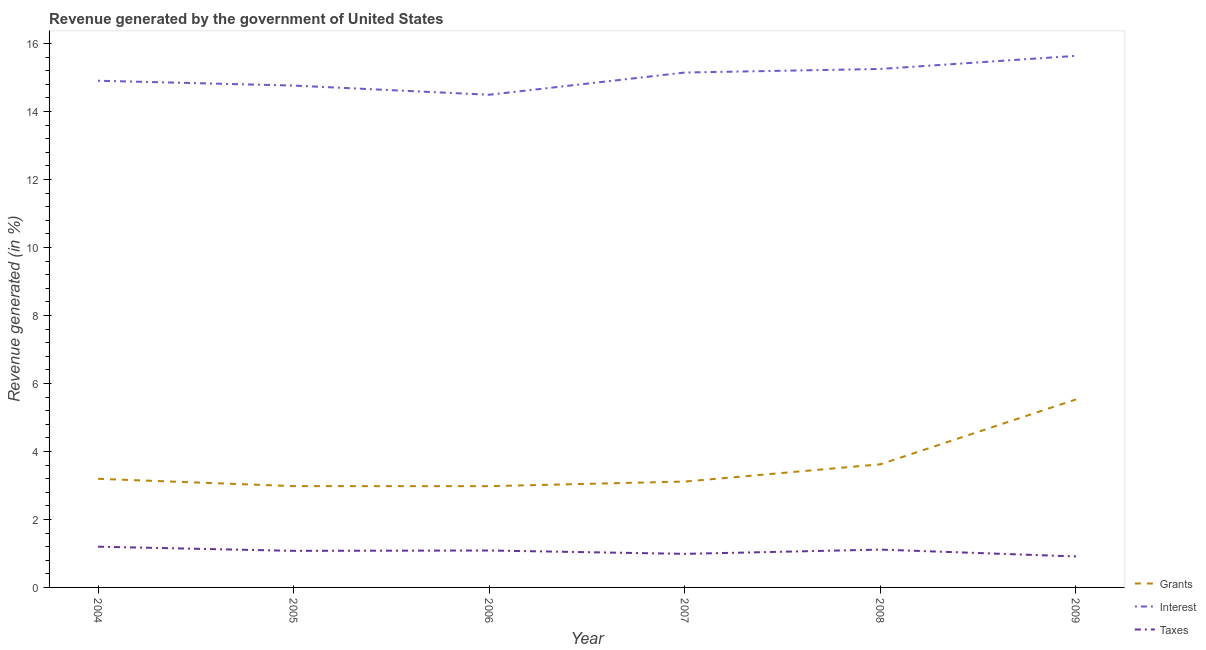How many different coloured lines are there?
Your answer should be very brief. 3. Is the number of lines equal to the number of legend labels?
Your answer should be compact. Yes. What is the percentage of revenue generated by grants in 2005?
Make the answer very short. 2.98. Across all years, what is the maximum percentage of revenue generated by interest?
Offer a very short reply. 15.64. Across all years, what is the minimum percentage of revenue generated by interest?
Keep it short and to the point. 14.49. In which year was the percentage of revenue generated by interest minimum?
Ensure brevity in your answer.  2006. What is the total percentage of revenue generated by interest in the graph?
Offer a terse response. 90.19. What is the difference between the percentage of revenue generated by interest in 2007 and that in 2009?
Your answer should be very brief. -0.49. What is the difference between the percentage of revenue generated by interest in 2005 and the percentage of revenue generated by grants in 2009?
Make the answer very short. 9.23. What is the average percentage of revenue generated by interest per year?
Your answer should be very brief. 15.03. In the year 2004, what is the difference between the percentage of revenue generated by interest and percentage of revenue generated by grants?
Offer a very short reply. 11.71. In how many years, is the percentage of revenue generated by grants greater than 7.2 %?
Your response must be concise. 0. What is the ratio of the percentage of revenue generated by taxes in 2006 to that in 2009?
Offer a very short reply. 1.19. What is the difference between the highest and the second highest percentage of revenue generated by grants?
Ensure brevity in your answer.  1.91. What is the difference between the highest and the lowest percentage of revenue generated by interest?
Your response must be concise. 1.14. In how many years, is the percentage of revenue generated by interest greater than the average percentage of revenue generated by interest taken over all years?
Keep it short and to the point. 3. Is the sum of the percentage of revenue generated by grants in 2005 and 2009 greater than the maximum percentage of revenue generated by taxes across all years?
Your answer should be compact. Yes. Is it the case that in every year, the sum of the percentage of revenue generated by grants and percentage of revenue generated by interest is greater than the percentage of revenue generated by taxes?
Your answer should be very brief. Yes. How many lines are there?
Your answer should be very brief. 3. How many years are there in the graph?
Give a very brief answer. 6. What is the difference between two consecutive major ticks on the Y-axis?
Make the answer very short. 2. Are the values on the major ticks of Y-axis written in scientific E-notation?
Offer a terse response. No. Does the graph contain any zero values?
Provide a short and direct response. No. Where does the legend appear in the graph?
Offer a terse response. Bottom right. How many legend labels are there?
Make the answer very short. 3. How are the legend labels stacked?
Your response must be concise. Vertical. What is the title of the graph?
Keep it short and to the point. Revenue generated by the government of United States. What is the label or title of the Y-axis?
Your answer should be compact. Revenue generated (in %). What is the Revenue generated (in %) in Grants in 2004?
Offer a very short reply. 3.2. What is the Revenue generated (in %) in Interest in 2004?
Your response must be concise. 14.9. What is the Revenue generated (in %) of Taxes in 2004?
Your answer should be very brief. 1.2. What is the Revenue generated (in %) of Grants in 2005?
Your response must be concise. 2.98. What is the Revenue generated (in %) in Interest in 2005?
Your answer should be compact. 14.76. What is the Revenue generated (in %) in Taxes in 2005?
Keep it short and to the point. 1.08. What is the Revenue generated (in %) in Grants in 2006?
Ensure brevity in your answer.  2.98. What is the Revenue generated (in %) in Interest in 2006?
Your answer should be very brief. 14.49. What is the Revenue generated (in %) in Taxes in 2006?
Provide a succinct answer. 1.09. What is the Revenue generated (in %) in Grants in 2007?
Give a very brief answer. 3.11. What is the Revenue generated (in %) in Interest in 2007?
Keep it short and to the point. 15.15. What is the Revenue generated (in %) in Taxes in 2007?
Provide a succinct answer. 0.99. What is the Revenue generated (in %) in Grants in 2008?
Ensure brevity in your answer.  3.62. What is the Revenue generated (in %) in Interest in 2008?
Your response must be concise. 15.25. What is the Revenue generated (in %) of Taxes in 2008?
Your answer should be very brief. 1.11. What is the Revenue generated (in %) of Grants in 2009?
Give a very brief answer. 5.53. What is the Revenue generated (in %) in Interest in 2009?
Give a very brief answer. 15.64. What is the Revenue generated (in %) in Taxes in 2009?
Ensure brevity in your answer.  0.91. Across all years, what is the maximum Revenue generated (in %) in Grants?
Your response must be concise. 5.53. Across all years, what is the maximum Revenue generated (in %) in Interest?
Provide a succinct answer. 15.64. Across all years, what is the maximum Revenue generated (in %) in Taxes?
Ensure brevity in your answer.  1.2. Across all years, what is the minimum Revenue generated (in %) of Grants?
Your answer should be compact. 2.98. Across all years, what is the minimum Revenue generated (in %) of Interest?
Your response must be concise. 14.49. Across all years, what is the minimum Revenue generated (in %) in Taxes?
Provide a succinct answer. 0.91. What is the total Revenue generated (in %) of Grants in the graph?
Offer a very short reply. 21.42. What is the total Revenue generated (in %) in Interest in the graph?
Ensure brevity in your answer.  90.19. What is the total Revenue generated (in %) of Taxes in the graph?
Give a very brief answer. 6.37. What is the difference between the Revenue generated (in %) in Grants in 2004 and that in 2005?
Offer a very short reply. 0.22. What is the difference between the Revenue generated (in %) of Interest in 2004 and that in 2005?
Your answer should be compact. 0.14. What is the difference between the Revenue generated (in %) in Taxes in 2004 and that in 2005?
Your response must be concise. 0.12. What is the difference between the Revenue generated (in %) of Grants in 2004 and that in 2006?
Your response must be concise. 0.22. What is the difference between the Revenue generated (in %) of Interest in 2004 and that in 2006?
Make the answer very short. 0.41. What is the difference between the Revenue generated (in %) in Taxes in 2004 and that in 2006?
Your response must be concise. 0.11. What is the difference between the Revenue generated (in %) in Grants in 2004 and that in 2007?
Provide a succinct answer. 0.08. What is the difference between the Revenue generated (in %) of Interest in 2004 and that in 2007?
Provide a succinct answer. -0.24. What is the difference between the Revenue generated (in %) of Taxes in 2004 and that in 2007?
Your response must be concise. 0.21. What is the difference between the Revenue generated (in %) of Grants in 2004 and that in 2008?
Offer a very short reply. -0.43. What is the difference between the Revenue generated (in %) of Interest in 2004 and that in 2008?
Offer a very short reply. -0.35. What is the difference between the Revenue generated (in %) in Taxes in 2004 and that in 2008?
Give a very brief answer. 0.09. What is the difference between the Revenue generated (in %) in Grants in 2004 and that in 2009?
Your answer should be very brief. -2.34. What is the difference between the Revenue generated (in %) in Interest in 2004 and that in 2009?
Your answer should be very brief. -0.73. What is the difference between the Revenue generated (in %) in Taxes in 2004 and that in 2009?
Keep it short and to the point. 0.29. What is the difference between the Revenue generated (in %) of Grants in 2005 and that in 2006?
Provide a short and direct response. 0. What is the difference between the Revenue generated (in %) in Interest in 2005 and that in 2006?
Your answer should be very brief. 0.27. What is the difference between the Revenue generated (in %) in Taxes in 2005 and that in 2006?
Provide a succinct answer. -0.01. What is the difference between the Revenue generated (in %) in Grants in 2005 and that in 2007?
Offer a terse response. -0.13. What is the difference between the Revenue generated (in %) in Interest in 2005 and that in 2007?
Keep it short and to the point. -0.38. What is the difference between the Revenue generated (in %) of Taxes in 2005 and that in 2007?
Make the answer very short. 0.09. What is the difference between the Revenue generated (in %) in Grants in 2005 and that in 2008?
Make the answer very short. -0.64. What is the difference between the Revenue generated (in %) of Interest in 2005 and that in 2008?
Give a very brief answer. -0.49. What is the difference between the Revenue generated (in %) in Taxes in 2005 and that in 2008?
Offer a terse response. -0.04. What is the difference between the Revenue generated (in %) of Grants in 2005 and that in 2009?
Provide a short and direct response. -2.55. What is the difference between the Revenue generated (in %) in Interest in 2005 and that in 2009?
Provide a short and direct response. -0.87. What is the difference between the Revenue generated (in %) of Taxes in 2005 and that in 2009?
Provide a succinct answer. 0.16. What is the difference between the Revenue generated (in %) in Grants in 2006 and that in 2007?
Your answer should be compact. -0.14. What is the difference between the Revenue generated (in %) in Interest in 2006 and that in 2007?
Your answer should be compact. -0.65. What is the difference between the Revenue generated (in %) of Taxes in 2006 and that in 2007?
Offer a terse response. 0.1. What is the difference between the Revenue generated (in %) in Grants in 2006 and that in 2008?
Offer a terse response. -0.64. What is the difference between the Revenue generated (in %) of Interest in 2006 and that in 2008?
Provide a short and direct response. -0.76. What is the difference between the Revenue generated (in %) in Taxes in 2006 and that in 2008?
Your answer should be compact. -0.03. What is the difference between the Revenue generated (in %) in Grants in 2006 and that in 2009?
Provide a succinct answer. -2.55. What is the difference between the Revenue generated (in %) of Interest in 2006 and that in 2009?
Your response must be concise. -1.14. What is the difference between the Revenue generated (in %) of Taxes in 2006 and that in 2009?
Offer a terse response. 0.17. What is the difference between the Revenue generated (in %) of Grants in 2007 and that in 2008?
Your response must be concise. -0.51. What is the difference between the Revenue generated (in %) in Interest in 2007 and that in 2008?
Provide a succinct answer. -0.11. What is the difference between the Revenue generated (in %) of Taxes in 2007 and that in 2008?
Give a very brief answer. -0.13. What is the difference between the Revenue generated (in %) of Grants in 2007 and that in 2009?
Your answer should be compact. -2.42. What is the difference between the Revenue generated (in %) of Interest in 2007 and that in 2009?
Your answer should be compact. -0.49. What is the difference between the Revenue generated (in %) in Taxes in 2007 and that in 2009?
Give a very brief answer. 0.08. What is the difference between the Revenue generated (in %) in Grants in 2008 and that in 2009?
Offer a very short reply. -1.91. What is the difference between the Revenue generated (in %) in Interest in 2008 and that in 2009?
Provide a short and direct response. -0.38. What is the difference between the Revenue generated (in %) in Taxes in 2008 and that in 2009?
Ensure brevity in your answer.  0.2. What is the difference between the Revenue generated (in %) in Grants in 2004 and the Revenue generated (in %) in Interest in 2005?
Your response must be concise. -11.57. What is the difference between the Revenue generated (in %) in Grants in 2004 and the Revenue generated (in %) in Taxes in 2005?
Your response must be concise. 2.12. What is the difference between the Revenue generated (in %) in Interest in 2004 and the Revenue generated (in %) in Taxes in 2005?
Give a very brief answer. 13.83. What is the difference between the Revenue generated (in %) in Grants in 2004 and the Revenue generated (in %) in Interest in 2006?
Offer a terse response. -11.3. What is the difference between the Revenue generated (in %) of Grants in 2004 and the Revenue generated (in %) of Taxes in 2006?
Your response must be concise. 2.11. What is the difference between the Revenue generated (in %) in Interest in 2004 and the Revenue generated (in %) in Taxes in 2006?
Keep it short and to the point. 13.82. What is the difference between the Revenue generated (in %) in Grants in 2004 and the Revenue generated (in %) in Interest in 2007?
Offer a very short reply. -11.95. What is the difference between the Revenue generated (in %) of Grants in 2004 and the Revenue generated (in %) of Taxes in 2007?
Give a very brief answer. 2.21. What is the difference between the Revenue generated (in %) of Interest in 2004 and the Revenue generated (in %) of Taxes in 2007?
Your answer should be very brief. 13.92. What is the difference between the Revenue generated (in %) in Grants in 2004 and the Revenue generated (in %) in Interest in 2008?
Provide a succinct answer. -12.06. What is the difference between the Revenue generated (in %) in Grants in 2004 and the Revenue generated (in %) in Taxes in 2008?
Make the answer very short. 2.08. What is the difference between the Revenue generated (in %) in Interest in 2004 and the Revenue generated (in %) in Taxes in 2008?
Provide a short and direct response. 13.79. What is the difference between the Revenue generated (in %) of Grants in 2004 and the Revenue generated (in %) of Interest in 2009?
Keep it short and to the point. -12.44. What is the difference between the Revenue generated (in %) in Grants in 2004 and the Revenue generated (in %) in Taxes in 2009?
Offer a very short reply. 2.28. What is the difference between the Revenue generated (in %) of Interest in 2004 and the Revenue generated (in %) of Taxes in 2009?
Offer a very short reply. 13.99. What is the difference between the Revenue generated (in %) of Grants in 2005 and the Revenue generated (in %) of Interest in 2006?
Your response must be concise. -11.51. What is the difference between the Revenue generated (in %) in Grants in 2005 and the Revenue generated (in %) in Taxes in 2006?
Give a very brief answer. 1.89. What is the difference between the Revenue generated (in %) of Interest in 2005 and the Revenue generated (in %) of Taxes in 2006?
Provide a short and direct response. 13.68. What is the difference between the Revenue generated (in %) of Grants in 2005 and the Revenue generated (in %) of Interest in 2007?
Offer a very short reply. -12.17. What is the difference between the Revenue generated (in %) of Grants in 2005 and the Revenue generated (in %) of Taxes in 2007?
Your answer should be very brief. 1.99. What is the difference between the Revenue generated (in %) in Interest in 2005 and the Revenue generated (in %) in Taxes in 2007?
Make the answer very short. 13.77. What is the difference between the Revenue generated (in %) of Grants in 2005 and the Revenue generated (in %) of Interest in 2008?
Ensure brevity in your answer.  -12.27. What is the difference between the Revenue generated (in %) of Grants in 2005 and the Revenue generated (in %) of Taxes in 2008?
Your response must be concise. 1.87. What is the difference between the Revenue generated (in %) of Interest in 2005 and the Revenue generated (in %) of Taxes in 2008?
Your answer should be very brief. 13.65. What is the difference between the Revenue generated (in %) in Grants in 2005 and the Revenue generated (in %) in Interest in 2009?
Your answer should be very brief. -12.66. What is the difference between the Revenue generated (in %) in Grants in 2005 and the Revenue generated (in %) in Taxes in 2009?
Offer a very short reply. 2.07. What is the difference between the Revenue generated (in %) in Interest in 2005 and the Revenue generated (in %) in Taxes in 2009?
Make the answer very short. 13.85. What is the difference between the Revenue generated (in %) of Grants in 2006 and the Revenue generated (in %) of Interest in 2007?
Keep it short and to the point. -12.17. What is the difference between the Revenue generated (in %) in Grants in 2006 and the Revenue generated (in %) in Taxes in 2007?
Ensure brevity in your answer.  1.99. What is the difference between the Revenue generated (in %) in Interest in 2006 and the Revenue generated (in %) in Taxes in 2007?
Offer a very short reply. 13.5. What is the difference between the Revenue generated (in %) in Grants in 2006 and the Revenue generated (in %) in Interest in 2008?
Give a very brief answer. -12.27. What is the difference between the Revenue generated (in %) in Grants in 2006 and the Revenue generated (in %) in Taxes in 2008?
Offer a very short reply. 1.87. What is the difference between the Revenue generated (in %) of Interest in 2006 and the Revenue generated (in %) of Taxes in 2008?
Make the answer very short. 13.38. What is the difference between the Revenue generated (in %) of Grants in 2006 and the Revenue generated (in %) of Interest in 2009?
Make the answer very short. -12.66. What is the difference between the Revenue generated (in %) in Grants in 2006 and the Revenue generated (in %) in Taxes in 2009?
Keep it short and to the point. 2.07. What is the difference between the Revenue generated (in %) of Interest in 2006 and the Revenue generated (in %) of Taxes in 2009?
Keep it short and to the point. 13.58. What is the difference between the Revenue generated (in %) in Grants in 2007 and the Revenue generated (in %) in Interest in 2008?
Give a very brief answer. -12.14. What is the difference between the Revenue generated (in %) in Grants in 2007 and the Revenue generated (in %) in Taxes in 2008?
Provide a short and direct response. 2. What is the difference between the Revenue generated (in %) in Interest in 2007 and the Revenue generated (in %) in Taxes in 2008?
Your answer should be compact. 14.03. What is the difference between the Revenue generated (in %) in Grants in 2007 and the Revenue generated (in %) in Interest in 2009?
Offer a very short reply. -12.52. What is the difference between the Revenue generated (in %) in Grants in 2007 and the Revenue generated (in %) in Taxes in 2009?
Your answer should be very brief. 2.2. What is the difference between the Revenue generated (in %) in Interest in 2007 and the Revenue generated (in %) in Taxes in 2009?
Offer a very short reply. 14.23. What is the difference between the Revenue generated (in %) of Grants in 2008 and the Revenue generated (in %) of Interest in 2009?
Your answer should be compact. -12.01. What is the difference between the Revenue generated (in %) of Grants in 2008 and the Revenue generated (in %) of Taxes in 2009?
Offer a terse response. 2.71. What is the difference between the Revenue generated (in %) of Interest in 2008 and the Revenue generated (in %) of Taxes in 2009?
Keep it short and to the point. 14.34. What is the average Revenue generated (in %) of Grants per year?
Offer a very short reply. 3.57. What is the average Revenue generated (in %) of Interest per year?
Provide a succinct answer. 15.03. What is the average Revenue generated (in %) of Taxes per year?
Provide a succinct answer. 1.06. In the year 2004, what is the difference between the Revenue generated (in %) of Grants and Revenue generated (in %) of Interest?
Give a very brief answer. -11.71. In the year 2004, what is the difference between the Revenue generated (in %) in Grants and Revenue generated (in %) in Taxes?
Your answer should be compact. 2. In the year 2004, what is the difference between the Revenue generated (in %) in Interest and Revenue generated (in %) in Taxes?
Provide a short and direct response. 13.71. In the year 2005, what is the difference between the Revenue generated (in %) of Grants and Revenue generated (in %) of Interest?
Keep it short and to the point. -11.78. In the year 2005, what is the difference between the Revenue generated (in %) in Grants and Revenue generated (in %) in Taxes?
Offer a very short reply. 1.9. In the year 2005, what is the difference between the Revenue generated (in %) of Interest and Revenue generated (in %) of Taxes?
Provide a short and direct response. 13.69. In the year 2006, what is the difference between the Revenue generated (in %) of Grants and Revenue generated (in %) of Interest?
Provide a succinct answer. -11.51. In the year 2006, what is the difference between the Revenue generated (in %) of Grants and Revenue generated (in %) of Taxes?
Your response must be concise. 1.89. In the year 2006, what is the difference between the Revenue generated (in %) in Interest and Revenue generated (in %) in Taxes?
Your answer should be very brief. 13.41. In the year 2007, what is the difference between the Revenue generated (in %) in Grants and Revenue generated (in %) in Interest?
Provide a short and direct response. -12.03. In the year 2007, what is the difference between the Revenue generated (in %) in Grants and Revenue generated (in %) in Taxes?
Your response must be concise. 2.13. In the year 2007, what is the difference between the Revenue generated (in %) of Interest and Revenue generated (in %) of Taxes?
Provide a short and direct response. 14.16. In the year 2008, what is the difference between the Revenue generated (in %) in Grants and Revenue generated (in %) in Interest?
Provide a succinct answer. -11.63. In the year 2008, what is the difference between the Revenue generated (in %) of Grants and Revenue generated (in %) of Taxes?
Give a very brief answer. 2.51. In the year 2008, what is the difference between the Revenue generated (in %) in Interest and Revenue generated (in %) in Taxes?
Make the answer very short. 14.14. In the year 2009, what is the difference between the Revenue generated (in %) in Grants and Revenue generated (in %) in Interest?
Your answer should be very brief. -10.11. In the year 2009, what is the difference between the Revenue generated (in %) of Grants and Revenue generated (in %) of Taxes?
Ensure brevity in your answer.  4.62. In the year 2009, what is the difference between the Revenue generated (in %) of Interest and Revenue generated (in %) of Taxes?
Your answer should be very brief. 14.72. What is the ratio of the Revenue generated (in %) in Grants in 2004 to that in 2005?
Offer a terse response. 1.07. What is the ratio of the Revenue generated (in %) in Interest in 2004 to that in 2005?
Keep it short and to the point. 1.01. What is the ratio of the Revenue generated (in %) in Taxes in 2004 to that in 2005?
Keep it short and to the point. 1.11. What is the ratio of the Revenue generated (in %) of Grants in 2004 to that in 2006?
Provide a short and direct response. 1.07. What is the ratio of the Revenue generated (in %) in Interest in 2004 to that in 2006?
Provide a succinct answer. 1.03. What is the ratio of the Revenue generated (in %) of Taxes in 2004 to that in 2006?
Offer a terse response. 1.1. What is the ratio of the Revenue generated (in %) in Grants in 2004 to that in 2007?
Provide a succinct answer. 1.03. What is the ratio of the Revenue generated (in %) of Interest in 2004 to that in 2007?
Ensure brevity in your answer.  0.98. What is the ratio of the Revenue generated (in %) of Taxes in 2004 to that in 2007?
Keep it short and to the point. 1.21. What is the ratio of the Revenue generated (in %) of Grants in 2004 to that in 2008?
Keep it short and to the point. 0.88. What is the ratio of the Revenue generated (in %) of Interest in 2004 to that in 2008?
Offer a terse response. 0.98. What is the ratio of the Revenue generated (in %) of Taxes in 2004 to that in 2008?
Make the answer very short. 1.08. What is the ratio of the Revenue generated (in %) in Grants in 2004 to that in 2009?
Provide a short and direct response. 0.58. What is the ratio of the Revenue generated (in %) of Interest in 2004 to that in 2009?
Offer a very short reply. 0.95. What is the ratio of the Revenue generated (in %) in Taxes in 2004 to that in 2009?
Your answer should be compact. 1.31. What is the ratio of the Revenue generated (in %) of Interest in 2005 to that in 2006?
Your answer should be very brief. 1.02. What is the ratio of the Revenue generated (in %) of Taxes in 2005 to that in 2006?
Your answer should be compact. 0.99. What is the ratio of the Revenue generated (in %) of Interest in 2005 to that in 2007?
Offer a terse response. 0.97. What is the ratio of the Revenue generated (in %) in Taxes in 2005 to that in 2007?
Keep it short and to the point. 1.09. What is the ratio of the Revenue generated (in %) of Grants in 2005 to that in 2008?
Make the answer very short. 0.82. What is the ratio of the Revenue generated (in %) in Interest in 2005 to that in 2008?
Make the answer very short. 0.97. What is the ratio of the Revenue generated (in %) of Taxes in 2005 to that in 2008?
Keep it short and to the point. 0.97. What is the ratio of the Revenue generated (in %) of Grants in 2005 to that in 2009?
Make the answer very short. 0.54. What is the ratio of the Revenue generated (in %) in Interest in 2005 to that in 2009?
Make the answer very short. 0.94. What is the ratio of the Revenue generated (in %) of Taxes in 2005 to that in 2009?
Give a very brief answer. 1.18. What is the ratio of the Revenue generated (in %) of Grants in 2006 to that in 2007?
Your answer should be compact. 0.96. What is the ratio of the Revenue generated (in %) of Interest in 2006 to that in 2007?
Offer a terse response. 0.96. What is the ratio of the Revenue generated (in %) in Taxes in 2006 to that in 2007?
Make the answer very short. 1.1. What is the ratio of the Revenue generated (in %) of Grants in 2006 to that in 2008?
Your answer should be very brief. 0.82. What is the ratio of the Revenue generated (in %) in Interest in 2006 to that in 2008?
Your response must be concise. 0.95. What is the ratio of the Revenue generated (in %) of Taxes in 2006 to that in 2008?
Make the answer very short. 0.98. What is the ratio of the Revenue generated (in %) of Grants in 2006 to that in 2009?
Keep it short and to the point. 0.54. What is the ratio of the Revenue generated (in %) of Interest in 2006 to that in 2009?
Your answer should be very brief. 0.93. What is the ratio of the Revenue generated (in %) of Taxes in 2006 to that in 2009?
Provide a short and direct response. 1.19. What is the ratio of the Revenue generated (in %) of Grants in 2007 to that in 2008?
Ensure brevity in your answer.  0.86. What is the ratio of the Revenue generated (in %) in Interest in 2007 to that in 2008?
Your answer should be very brief. 0.99. What is the ratio of the Revenue generated (in %) in Taxes in 2007 to that in 2008?
Offer a very short reply. 0.89. What is the ratio of the Revenue generated (in %) in Grants in 2007 to that in 2009?
Ensure brevity in your answer.  0.56. What is the ratio of the Revenue generated (in %) of Interest in 2007 to that in 2009?
Provide a succinct answer. 0.97. What is the ratio of the Revenue generated (in %) in Taxes in 2007 to that in 2009?
Your answer should be compact. 1.08. What is the ratio of the Revenue generated (in %) of Grants in 2008 to that in 2009?
Your response must be concise. 0.65. What is the ratio of the Revenue generated (in %) of Interest in 2008 to that in 2009?
Offer a terse response. 0.98. What is the ratio of the Revenue generated (in %) of Taxes in 2008 to that in 2009?
Give a very brief answer. 1.22. What is the difference between the highest and the second highest Revenue generated (in %) in Grants?
Make the answer very short. 1.91. What is the difference between the highest and the second highest Revenue generated (in %) of Interest?
Offer a very short reply. 0.38. What is the difference between the highest and the second highest Revenue generated (in %) of Taxes?
Your answer should be very brief. 0.09. What is the difference between the highest and the lowest Revenue generated (in %) in Grants?
Offer a very short reply. 2.55. What is the difference between the highest and the lowest Revenue generated (in %) of Interest?
Your response must be concise. 1.14. What is the difference between the highest and the lowest Revenue generated (in %) in Taxes?
Offer a terse response. 0.29. 